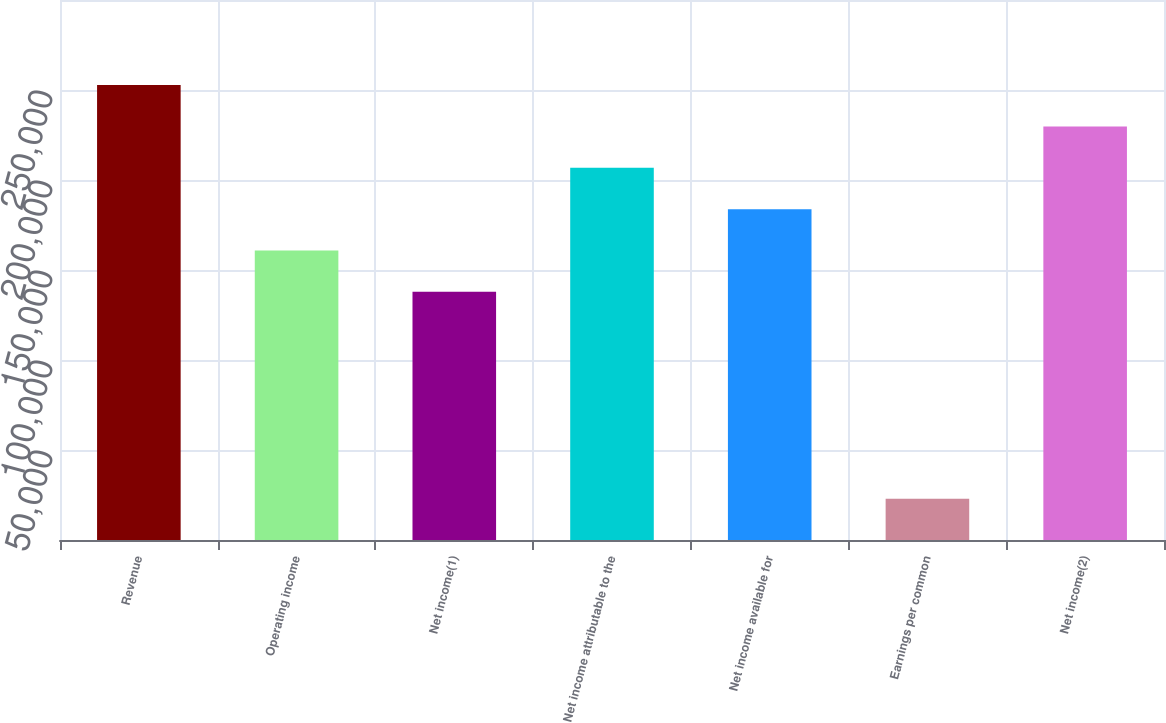Convert chart to OTSL. <chart><loc_0><loc_0><loc_500><loc_500><bar_chart><fcel>Revenue<fcel>Operating income<fcel>Net income(1)<fcel>Net income attributable to the<fcel>Net income available for<fcel>Earnings per common<fcel>Net income(2)<nl><fcel>252728<fcel>160827<fcel>137852<fcel>206778<fcel>183803<fcel>22976<fcel>229753<nl></chart> 